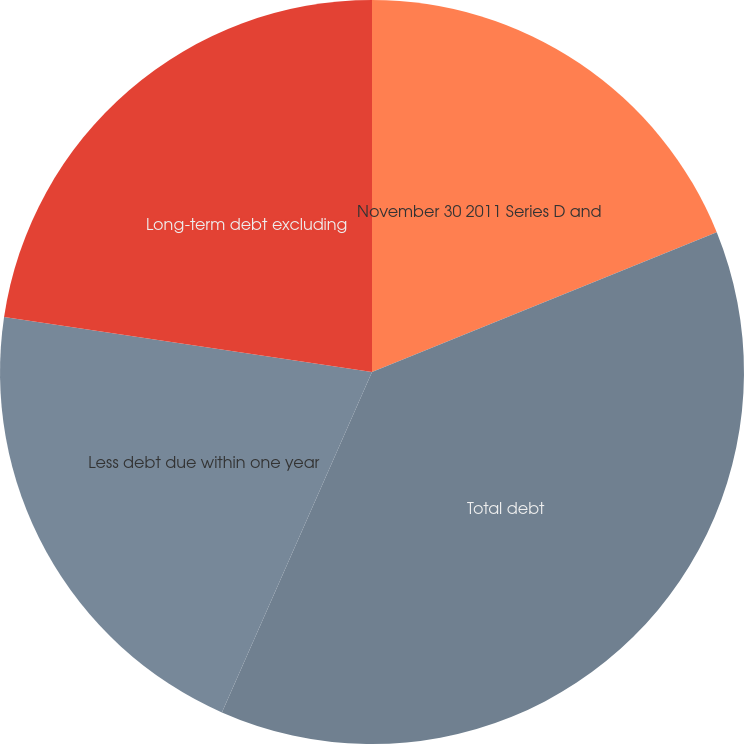Convert chart. <chart><loc_0><loc_0><loc_500><loc_500><pie_chart><fcel>November 30 2011 Series D and<fcel>Total debt<fcel>Less debt due within one year<fcel>Long-term debt excluding<nl><fcel>18.87%<fcel>37.74%<fcel>20.75%<fcel>22.64%<nl></chart> 